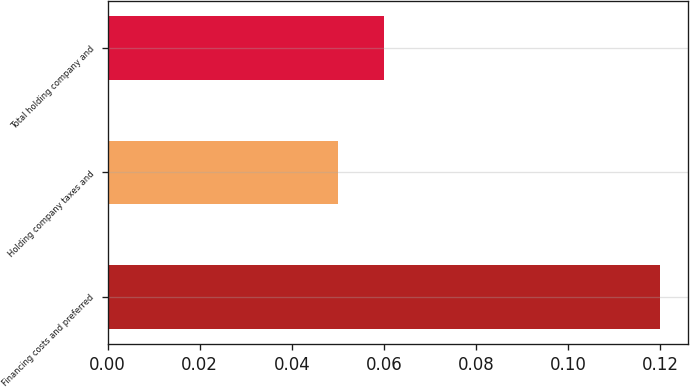<chart> <loc_0><loc_0><loc_500><loc_500><bar_chart><fcel>Financing costs and preferred<fcel>Holding company taxes and<fcel>Total holding company and<nl><fcel>0.12<fcel>0.05<fcel>0.06<nl></chart> 